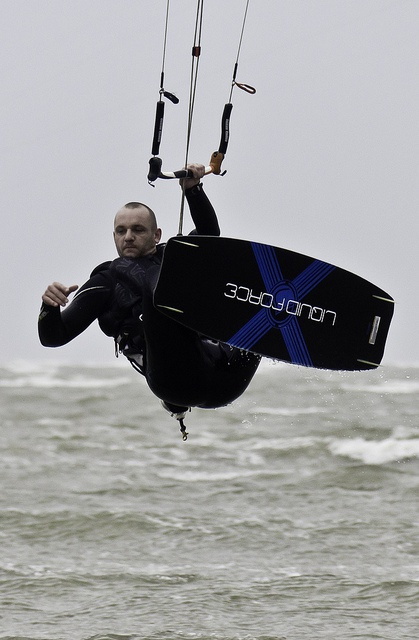Describe the objects in this image and their specific colors. I can see people in lightgray, black, navy, gray, and darkgray tones and surfboard in lightgray, black, navy, and gray tones in this image. 